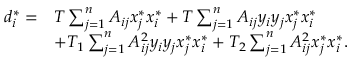<formula> <loc_0><loc_0><loc_500><loc_500>\begin{array} { r l } { d _ { i } ^ { * } = } & { T \sum _ { j = 1 } ^ { n } A _ { i j } x _ { j } ^ { * } x _ { i } ^ { * } + T \sum _ { j = 1 } ^ { n } A _ { i j } y _ { i } y _ { j } x _ { j } ^ { * } x _ { i } ^ { * } } \\ & { + T _ { 1 } \sum _ { j = 1 } ^ { n } A _ { i j } ^ { 2 } y _ { i } y _ { j } x _ { j } ^ { * } x _ { i } ^ { * } + T _ { 2 } \sum _ { j = 1 } ^ { n } A _ { i j } ^ { 2 } x _ { j } ^ { * } x _ { i } ^ { * } . } \end{array}</formula> 